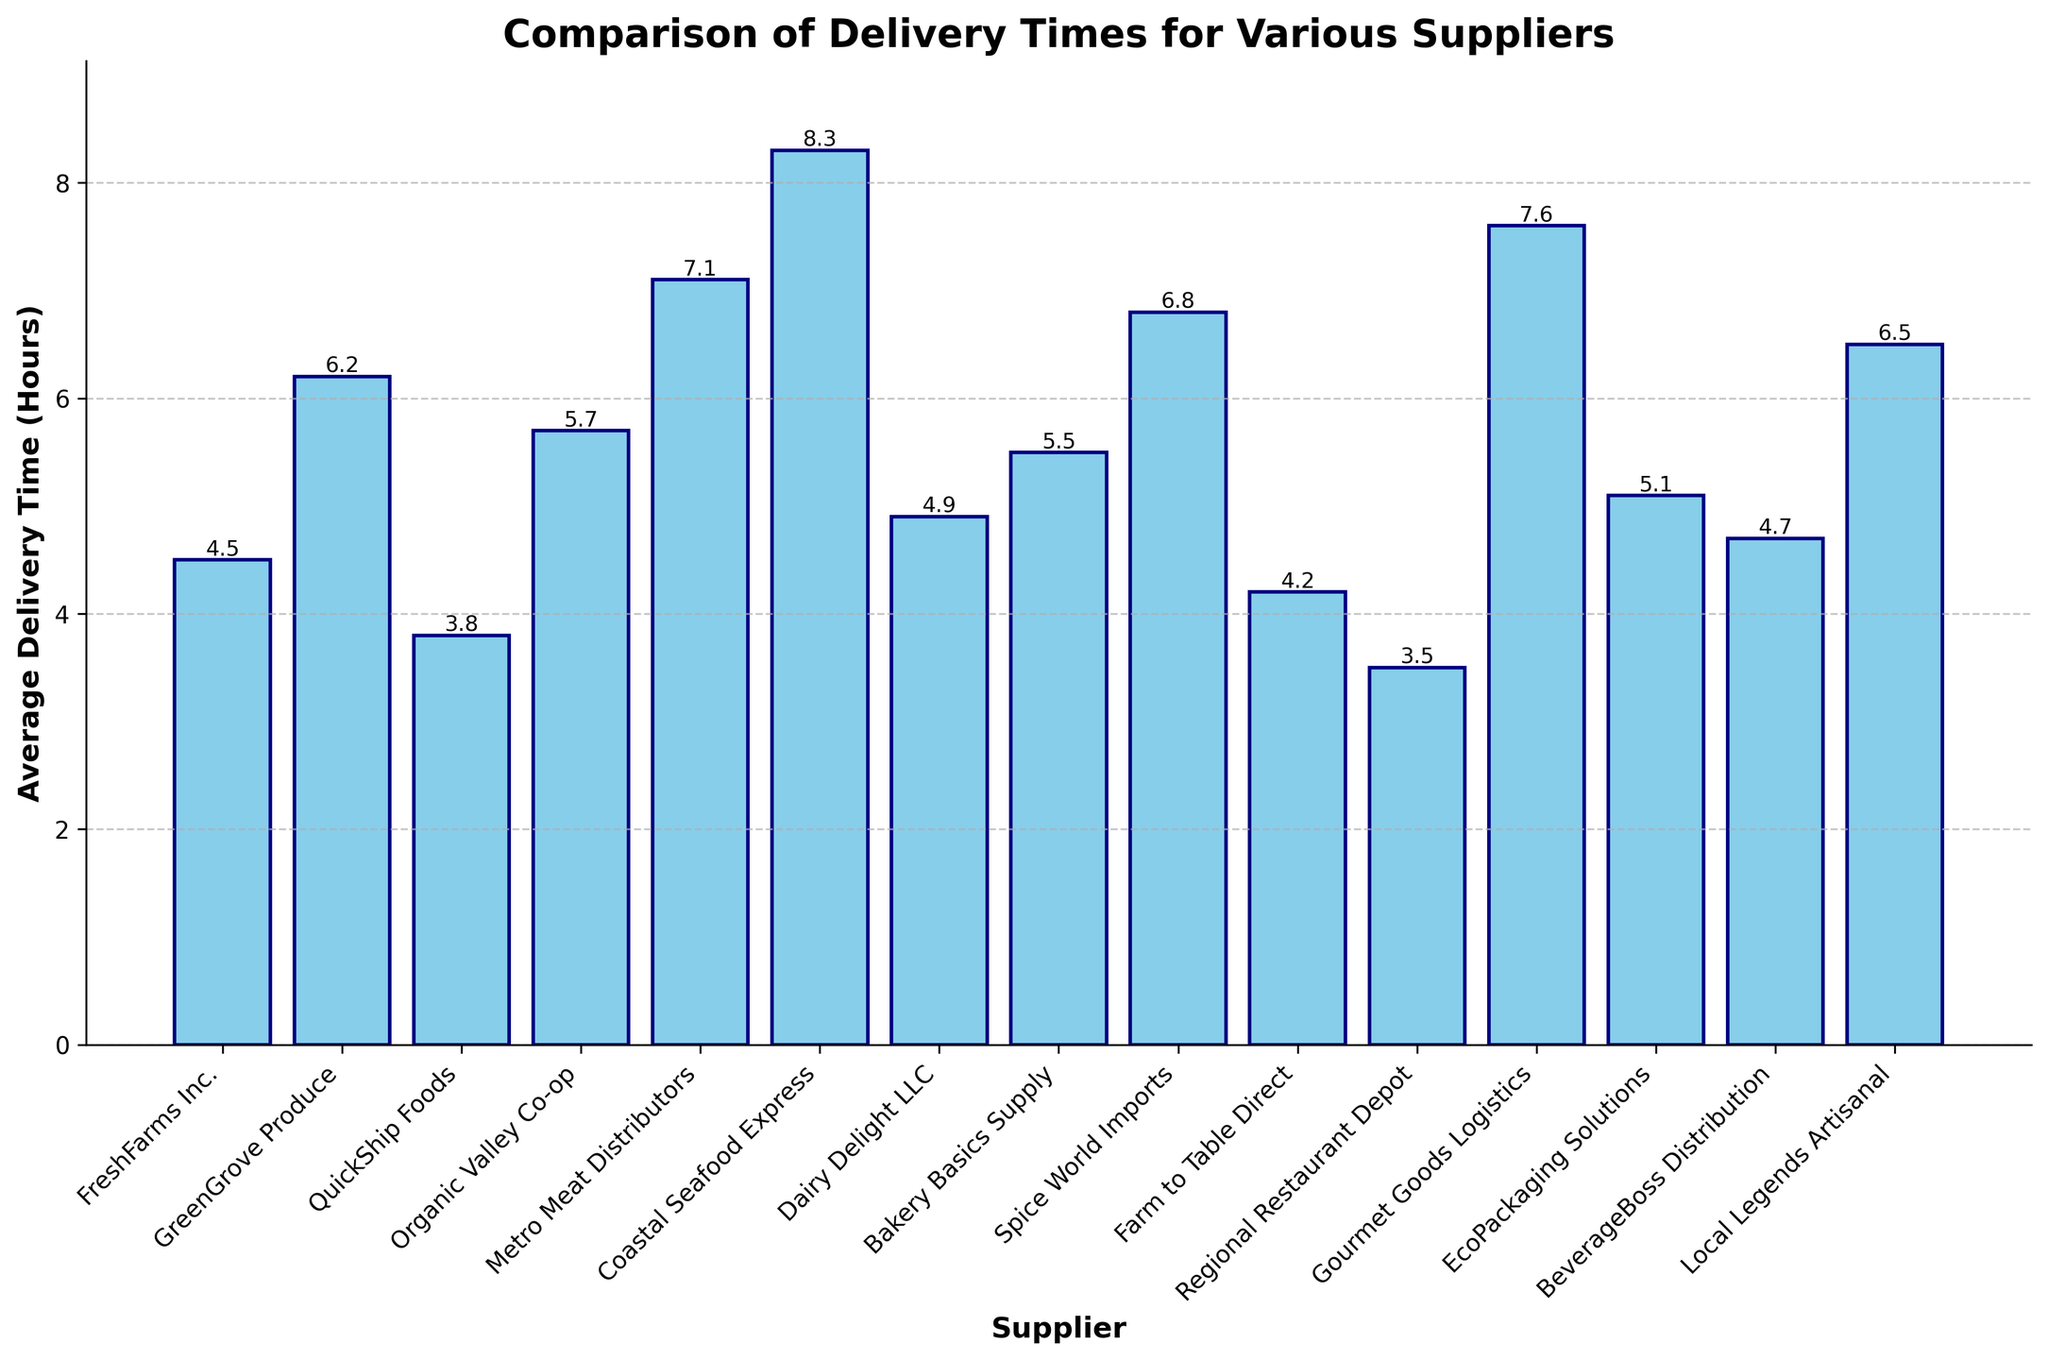What's the average delivery time for suppliers whose names start with 'B'? The suppliers starting with 'B' are Bakery Basics Supply and BeverageBoss Distribution. Their average delivery times are 5.5 hours and 4.7 hours respectively. The average delivery time is (5.5 + 4.7) / 2 = 5.1 hours
Answer: 5.1 hours Which supplier has the shortest average delivery time? The shortest average delivery time is shown by the shortest bar. Regional Restaurant Depot has the shortest delivery time of 3.5 hours
Answer: Regional Restaurant Depot How much longer is Coastal Seafood Express's delivery time compared to QuickShip Foods? Coastal Seafood Express has an average delivery time of 8.3 hours, while QuickShip Foods has 3.8 hours. The difference is 8.3 - 3.8 = 4.5 hours
Answer: 4.5 hours What is the median delivery time across all suppliers? List the delivery times in ascending order: 3.5, 3.8, 4.2, 4.5, 4.7, 4.9, 5.1, 5.5, 5.7, 6.2, 6.5, 6.8, 7.1, 7.6, 8.3. The middle value is the 8th in the sorted list, which is 5.5 hours
Answer: 5.5 hours Which two suppliers have the closest average delivery times? Compare the delivery times: FreshFarms Inc. (4.5), GreenGrove Produce (6.2), QuickShip Foods (3.8), Organic Valley Co-op (5.7), Metro Meat Distributors (7.1), Coastal Seafood Express (8.3), Dairy Delight LLC (4.9), Bakery Basics Supply (5.5), Spice World Imports (6.8), Farm to Table Direct (4.2), Regional Restaurant Depot (3.5), Gourmet Goods Logistics (7.6), EcoPackaging Solutions (5.1), BeverageBoss Distribution (4.7), Local Legends Artisanal (6.5). The smallest difference is between FreshFarms Inc. (4.5) and Dairy Delight LLC (4.9), a difference of 0.4 hours
Answer: FreshFarms Inc. and Dairy Delight LLC What is the combined delivery time for FreshFarms Inc. and Dairy Delight LLC? The delivery times for FreshFarms Inc. and Dairy Delight LLC are 4.5 hours and 4.9 hours respectively. Their combined delivery time is 4.5 + 4.9 = 9.4 hours
Answer: 9.4 hours Rank the suppliers from the shortest to the longest average delivery time. Sorted list according to the height of the bars: Regional Restaurant Depot (3.5), QuickShip Foods (3.8), Farm to Table Direct (4.2), FreshFarms Inc. (4.5), BeverageBoss Distribution (4.7), Dairy Delight LLC (4.9), EcoPackaging Solutions (5.1), Bakery Basics Supply (5.5), Organic Valley Co-op (5.7), GreenGrove Produce (6.2), Local Legends Artisanal (6.5), Spice World Imports (6.8), Metro Meat Distributors (7.1), Gourmet Goods Logistics (7.6), Coastal Seafood Express (8.3)
Answer: Regional Restaurant Depot, QuickShip Foods, Farm to Table Direct, FreshFarms Inc., BeverageBoss Distribution, Dairy Delight LLC, EcoPackaging Solutions, Bakery Basics Supply, Organic Valley Co-op, GreenGrove Produce, Local Legends Artisanal, Spice World Imports, Metro Meat Distributors, Gourmet Goods Logistics, Coastal Seafood Express 